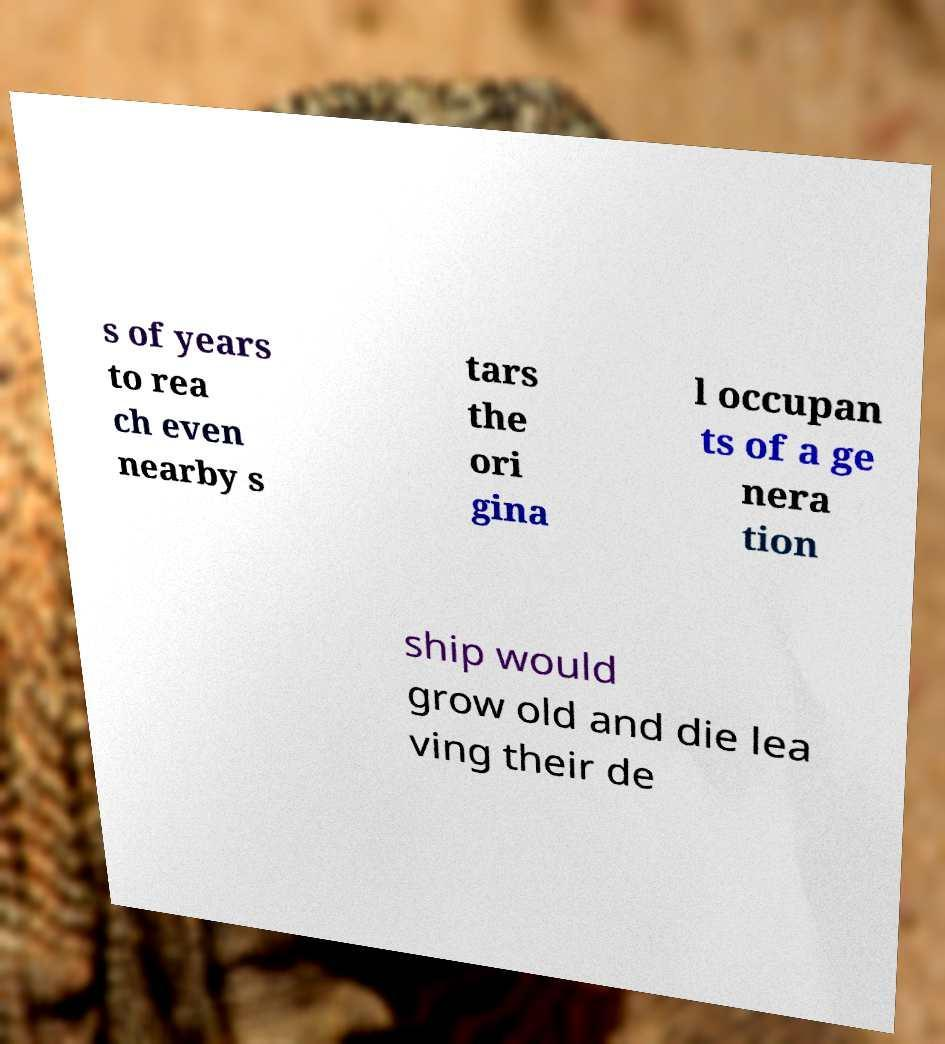Can you accurately transcribe the text from the provided image for me? s of years to rea ch even nearby s tars the ori gina l occupan ts of a ge nera tion ship would grow old and die lea ving their de 